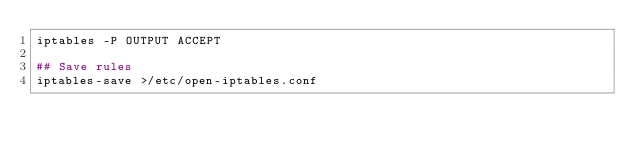<code> <loc_0><loc_0><loc_500><loc_500><_Bash_>iptables -P OUTPUT ACCEPT

## Save rules
iptables-save >/etc/open-iptables.conf
</code> 